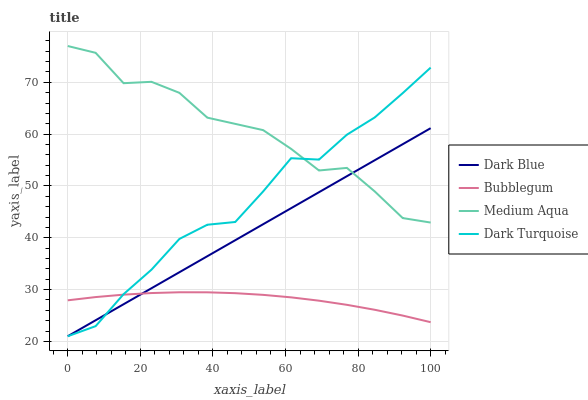Does Bubblegum have the minimum area under the curve?
Answer yes or no. Yes. Does Medium Aqua have the maximum area under the curve?
Answer yes or no. Yes. Does Medium Aqua have the minimum area under the curve?
Answer yes or no. No. Does Bubblegum have the maximum area under the curve?
Answer yes or no. No. Is Dark Blue the smoothest?
Answer yes or no. Yes. Is Medium Aqua the roughest?
Answer yes or no. Yes. Is Bubblegum the smoothest?
Answer yes or no. No. Is Bubblegum the roughest?
Answer yes or no. No. Does Dark Blue have the lowest value?
Answer yes or no. Yes. Does Bubblegum have the lowest value?
Answer yes or no. No. Does Medium Aqua have the highest value?
Answer yes or no. Yes. Does Bubblegum have the highest value?
Answer yes or no. No. Is Bubblegum less than Medium Aqua?
Answer yes or no. Yes. Is Medium Aqua greater than Bubblegum?
Answer yes or no. Yes. Does Dark Blue intersect Bubblegum?
Answer yes or no. Yes. Is Dark Blue less than Bubblegum?
Answer yes or no. No. Is Dark Blue greater than Bubblegum?
Answer yes or no. No. Does Bubblegum intersect Medium Aqua?
Answer yes or no. No. 